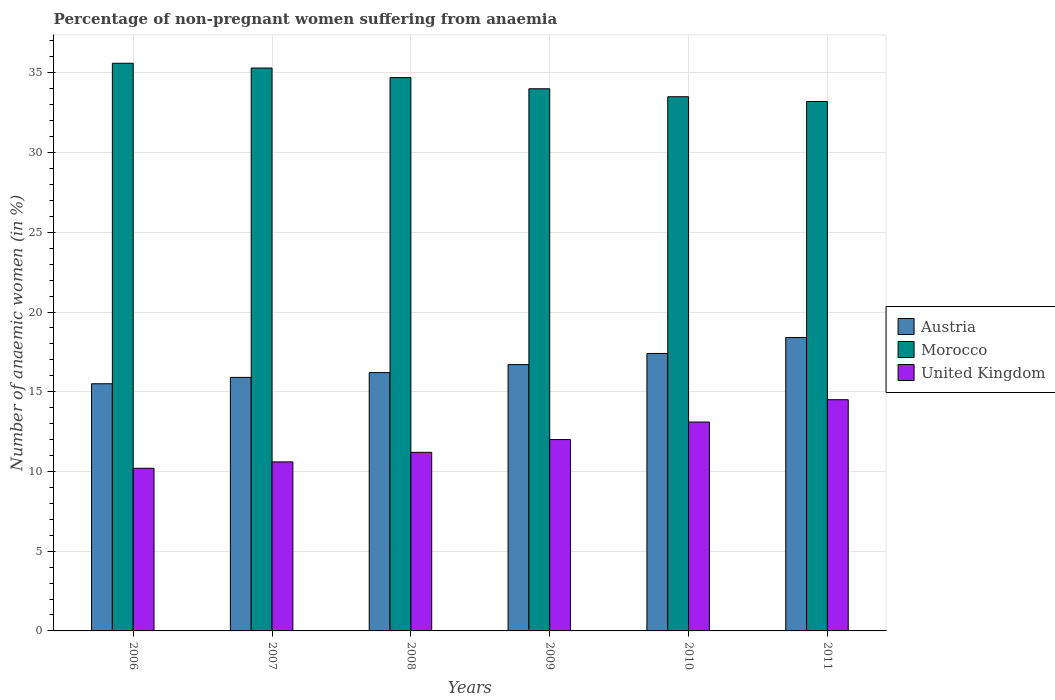How many different coloured bars are there?
Give a very brief answer. 3. Are the number of bars per tick equal to the number of legend labels?
Offer a terse response. Yes. What is the label of the 5th group of bars from the left?
Keep it short and to the point. 2010. In how many cases, is the number of bars for a given year not equal to the number of legend labels?
Provide a succinct answer. 0. Across all years, what is the maximum percentage of non-pregnant women suffering from anaemia in Morocco?
Provide a succinct answer. 35.6. What is the total percentage of non-pregnant women suffering from anaemia in Morocco in the graph?
Make the answer very short. 206.3. What is the difference between the percentage of non-pregnant women suffering from anaemia in Austria in 2008 and the percentage of non-pregnant women suffering from anaemia in Morocco in 2009?
Provide a short and direct response. -17.8. What is the average percentage of non-pregnant women suffering from anaemia in Austria per year?
Provide a succinct answer. 16.68. In the year 2009, what is the difference between the percentage of non-pregnant women suffering from anaemia in Austria and percentage of non-pregnant women suffering from anaemia in Morocco?
Offer a terse response. -17.3. What is the ratio of the percentage of non-pregnant women suffering from anaemia in Austria in 2007 to that in 2009?
Your answer should be compact. 0.95. Is the percentage of non-pregnant women suffering from anaemia in Austria in 2009 less than that in 2011?
Your answer should be very brief. Yes. Is the difference between the percentage of non-pregnant women suffering from anaemia in Austria in 2007 and 2010 greater than the difference between the percentage of non-pregnant women suffering from anaemia in Morocco in 2007 and 2010?
Ensure brevity in your answer.  No. What is the difference between the highest and the second highest percentage of non-pregnant women suffering from anaemia in Morocco?
Give a very brief answer. 0.3. What is the difference between the highest and the lowest percentage of non-pregnant women suffering from anaemia in Morocco?
Provide a short and direct response. 2.4. What does the 2nd bar from the left in 2008 represents?
Give a very brief answer. Morocco. Is it the case that in every year, the sum of the percentage of non-pregnant women suffering from anaemia in Austria and percentage of non-pregnant women suffering from anaemia in United Kingdom is greater than the percentage of non-pregnant women suffering from anaemia in Morocco?
Your answer should be very brief. No. What is the difference between two consecutive major ticks on the Y-axis?
Your answer should be compact. 5. Does the graph contain any zero values?
Your response must be concise. No. Does the graph contain grids?
Provide a succinct answer. Yes. What is the title of the graph?
Your response must be concise. Percentage of non-pregnant women suffering from anaemia. What is the label or title of the X-axis?
Provide a short and direct response. Years. What is the label or title of the Y-axis?
Ensure brevity in your answer.  Number of anaemic women (in %). What is the Number of anaemic women (in %) in Austria in 2006?
Your answer should be compact. 15.5. What is the Number of anaemic women (in %) in Morocco in 2006?
Your answer should be compact. 35.6. What is the Number of anaemic women (in %) of Morocco in 2007?
Provide a succinct answer. 35.3. What is the Number of anaemic women (in %) in United Kingdom in 2007?
Provide a short and direct response. 10.6. What is the Number of anaemic women (in %) in Morocco in 2008?
Your answer should be compact. 34.7. What is the Number of anaemic women (in %) in United Kingdom in 2008?
Provide a short and direct response. 11.2. What is the Number of anaemic women (in %) of Austria in 2009?
Your answer should be very brief. 16.7. What is the Number of anaemic women (in %) of Morocco in 2009?
Provide a short and direct response. 34. What is the Number of anaemic women (in %) of Austria in 2010?
Offer a very short reply. 17.4. What is the Number of anaemic women (in %) in Morocco in 2010?
Keep it short and to the point. 33.5. What is the Number of anaemic women (in %) of United Kingdom in 2010?
Give a very brief answer. 13.1. What is the Number of anaemic women (in %) of Morocco in 2011?
Your answer should be compact. 33.2. Across all years, what is the maximum Number of anaemic women (in %) in Morocco?
Offer a terse response. 35.6. Across all years, what is the maximum Number of anaemic women (in %) of United Kingdom?
Ensure brevity in your answer.  14.5. Across all years, what is the minimum Number of anaemic women (in %) of Austria?
Make the answer very short. 15.5. Across all years, what is the minimum Number of anaemic women (in %) of Morocco?
Provide a short and direct response. 33.2. What is the total Number of anaemic women (in %) of Austria in the graph?
Offer a terse response. 100.1. What is the total Number of anaemic women (in %) in Morocco in the graph?
Provide a short and direct response. 206.3. What is the total Number of anaemic women (in %) in United Kingdom in the graph?
Your response must be concise. 71.6. What is the difference between the Number of anaemic women (in %) in Austria in 2006 and that in 2007?
Your answer should be very brief. -0.4. What is the difference between the Number of anaemic women (in %) of Morocco in 2006 and that in 2008?
Make the answer very short. 0.9. What is the difference between the Number of anaemic women (in %) of United Kingdom in 2006 and that in 2008?
Your answer should be compact. -1. What is the difference between the Number of anaemic women (in %) in Morocco in 2006 and that in 2009?
Your answer should be compact. 1.6. What is the difference between the Number of anaemic women (in %) of United Kingdom in 2006 and that in 2009?
Keep it short and to the point. -1.8. What is the difference between the Number of anaemic women (in %) in Austria in 2006 and that in 2010?
Ensure brevity in your answer.  -1.9. What is the difference between the Number of anaemic women (in %) of Morocco in 2006 and that in 2011?
Offer a very short reply. 2.4. What is the difference between the Number of anaemic women (in %) in United Kingdom in 2006 and that in 2011?
Provide a succinct answer. -4.3. What is the difference between the Number of anaemic women (in %) in Morocco in 2007 and that in 2008?
Your response must be concise. 0.6. What is the difference between the Number of anaemic women (in %) of Austria in 2007 and that in 2009?
Your response must be concise. -0.8. What is the difference between the Number of anaemic women (in %) of Morocco in 2007 and that in 2009?
Make the answer very short. 1.3. What is the difference between the Number of anaemic women (in %) in United Kingdom in 2007 and that in 2009?
Your answer should be compact. -1.4. What is the difference between the Number of anaemic women (in %) of Morocco in 2007 and that in 2010?
Your answer should be very brief. 1.8. What is the difference between the Number of anaemic women (in %) in United Kingdom in 2007 and that in 2010?
Provide a short and direct response. -2.5. What is the difference between the Number of anaemic women (in %) in Austria in 2007 and that in 2011?
Provide a short and direct response. -2.5. What is the difference between the Number of anaemic women (in %) of Morocco in 2007 and that in 2011?
Make the answer very short. 2.1. What is the difference between the Number of anaemic women (in %) of Morocco in 2008 and that in 2009?
Your answer should be very brief. 0.7. What is the difference between the Number of anaemic women (in %) of Morocco in 2008 and that in 2010?
Offer a very short reply. 1.2. What is the difference between the Number of anaemic women (in %) of United Kingdom in 2008 and that in 2010?
Ensure brevity in your answer.  -1.9. What is the difference between the Number of anaemic women (in %) of United Kingdom in 2008 and that in 2011?
Provide a succinct answer. -3.3. What is the difference between the Number of anaemic women (in %) in Austria in 2009 and that in 2010?
Make the answer very short. -0.7. What is the difference between the Number of anaemic women (in %) in Morocco in 2009 and that in 2010?
Keep it short and to the point. 0.5. What is the difference between the Number of anaemic women (in %) of United Kingdom in 2009 and that in 2010?
Your answer should be compact. -1.1. What is the difference between the Number of anaemic women (in %) of Morocco in 2009 and that in 2011?
Make the answer very short. 0.8. What is the difference between the Number of anaemic women (in %) in United Kingdom in 2010 and that in 2011?
Offer a terse response. -1.4. What is the difference between the Number of anaemic women (in %) of Austria in 2006 and the Number of anaemic women (in %) of Morocco in 2007?
Provide a succinct answer. -19.8. What is the difference between the Number of anaemic women (in %) in Austria in 2006 and the Number of anaemic women (in %) in United Kingdom in 2007?
Your answer should be compact. 4.9. What is the difference between the Number of anaemic women (in %) in Morocco in 2006 and the Number of anaemic women (in %) in United Kingdom in 2007?
Give a very brief answer. 25. What is the difference between the Number of anaemic women (in %) of Austria in 2006 and the Number of anaemic women (in %) of Morocco in 2008?
Provide a succinct answer. -19.2. What is the difference between the Number of anaemic women (in %) in Austria in 2006 and the Number of anaemic women (in %) in United Kingdom in 2008?
Provide a short and direct response. 4.3. What is the difference between the Number of anaemic women (in %) in Morocco in 2006 and the Number of anaemic women (in %) in United Kingdom in 2008?
Offer a very short reply. 24.4. What is the difference between the Number of anaemic women (in %) in Austria in 2006 and the Number of anaemic women (in %) in Morocco in 2009?
Your answer should be compact. -18.5. What is the difference between the Number of anaemic women (in %) of Morocco in 2006 and the Number of anaemic women (in %) of United Kingdom in 2009?
Make the answer very short. 23.6. What is the difference between the Number of anaemic women (in %) of Austria in 2006 and the Number of anaemic women (in %) of Morocco in 2010?
Provide a short and direct response. -18. What is the difference between the Number of anaemic women (in %) in Austria in 2006 and the Number of anaemic women (in %) in United Kingdom in 2010?
Your answer should be compact. 2.4. What is the difference between the Number of anaemic women (in %) in Morocco in 2006 and the Number of anaemic women (in %) in United Kingdom in 2010?
Provide a succinct answer. 22.5. What is the difference between the Number of anaemic women (in %) of Austria in 2006 and the Number of anaemic women (in %) of Morocco in 2011?
Make the answer very short. -17.7. What is the difference between the Number of anaemic women (in %) of Morocco in 2006 and the Number of anaemic women (in %) of United Kingdom in 2011?
Offer a terse response. 21.1. What is the difference between the Number of anaemic women (in %) of Austria in 2007 and the Number of anaemic women (in %) of Morocco in 2008?
Provide a short and direct response. -18.8. What is the difference between the Number of anaemic women (in %) of Morocco in 2007 and the Number of anaemic women (in %) of United Kingdom in 2008?
Give a very brief answer. 24.1. What is the difference between the Number of anaemic women (in %) of Austria in 2007 and the Number of anaemic women (in %) of Morocco in 2009?
Ensure brevity in your answer.  -18.1. What is the difference between the Number of anaemic women (in %) in Austria in 2007 and the Number of anaemic women (in %) in United Kingdom in 2009?
Offer a terse response. 3.9. What is the difference between the Number of anaemic women (in %) in Morocco in 2007 and the Number of anaemic women (in %) in United Kingdom in 2009?
Make the answer very short. 23.3. What is the difference between the Number of anaemic women (in %) of Austria in 2007 and the Number of anaemic women (in %) of Morocco in 2010?
Offer a terse response. -17.6. What is the difference between the Number of anaemic women (in %) in Austria in 2007 and the Number of anaemic women (in %) in United Kingdom in 2010?
Provide a succinct answer. 2.8. What is the difference between the Number of anaemic women (in %) in Austria in 2007 and the Number of anaemic women (in %) in Morocco in 2011?
Keep it short and to the point. -17.3. What is the difference between the Number of anaemic women (in %) of Morocco in 2007 and the Number of anaemic women (in %) of United Kingdom in 2011?
Provide a succinct answer. 20.8. What is the difference between the Number of anaemic women (in %) in Austria in 2008 and the Number of anaemic women (in %) in Morocco in 2009?
Offer a terse response. -17.8. What is the difference between the Number of anaemic women (in %) in Austria in 2008 and the Number of anaemic women (in %) in United Kingdom in 2009?
Provide a short and direct response. 4.2. What is the difference between the Number of anaemic women (in %) of Morocco in 2008 and the Number of anaemic women (in %) of United Kingdom in 2009?
Your answer should be compact. 22.7. What is the difference between the Number of anaemic women (in %) in Austria in 2008 and the Number of anaemic women (in %) in Morocco in 2010?
Provide a short and direct response. -17.3. What is the difference between the Number of anaemic women (in %) of Morocco in 2008 and the Number of anaemic women (in %) of United Kingdom in 2010?
Give a very brief answer. 21.6. What is the difference between the Number of anaemic women (in %) in Austria in 2008 and the Number of anaemic women (in %) in Morocco in 2011?
Your answer should be very brief. -17. What is the difference between the Number of anaemic women (in %) in Morocco in 2008 and the Number of anaemic women (in %) in United Kingdom in 2011?
Your answer should be very brief. 20.2. What is the difference between the Number of anaemic women (in %) of Austria in 2009 and the Number of anaemic women (in %) of Morocco in 2010?
Give a very brief answer. -16.8. What is the difference between the Number of anaemic women (in %) of Morocco in 2009 and the Number of anaemic women (in %) of United Kingdom in 2010?
Provide a succinct answer. 20.9. What is the difference between the Number of anaemic women (in %) of Austria in 2009 and the Number of anaemic women (in %) of Morocco in 2011?
Ensure brevity in your answer.  -16.5. What is the difference between the Number of anaemic women (in %) in Morocco in 2009 and the Number of anaemic women (in %) in United Kingdom in 2011?
Offer a terse response. 19.5. What is the difference between the Number of anaemic women (in %) in Austria in 2010 and the Number of anaemic women (in %) in Morocco in 2011?
Offer a terse response. -15.8. What is the difference between the Number of anaemic women (in %) in Austria in 2010 and the Number of anaemic women (in %) in United Kingdom in 2011?
Offer a terse response. 2.9. What is the average Number of anaemic women (in %) of Austria per year?
Make the answer very short. 16.68. What is the average Number of anaemic women (in %) of Morocco per year?
Your answer should be very brief. 34.38. What is the average Number of anaemic women (in %) in United Kingdom per year?
Keep it short and to the point. 11.93. In the year 2006, what is the difference between the Number of anaemic women (in %) in Austria and Number of anaemic women (in %) in Morocco?
Make the answer very short. -20.1. In the year 2006, what is the difference between the Number of anaemic women (in %) of Austria and Number of anaemic women (in %) of United Kingdom?
Your answer should be compact. 5.3. In the year 2006, what is the difference between the Number of anaemic women (in %) of Morocco and Number of anaemic women (in %) of United Kingdom?
Your answer should be compact. 25.4. In the year 2007, what is the difference between the Number of anaemic women (in %) in Austria and Number of anaemic women (in %) in Morocco?
Give a very brief answer. -19.4. In the year 2007, what is the difference between the Number of anaemic women (in %) in Morocco and Number of anaemic women (in %) in United Kingdom?
Offer a very short reply. 24.7. In the year 2008, what is the difference between the Number of anaemic women (in %) of Austria and Number of anaemic women (in %) of Morocco?
Provide a succinct answer. -18.5. In the year 2008, what is the difference between the Number of anaemic women (in %) of Austria and Number of anaemic women (in %) of United Kingdom?
Offer a terse response. 5. In the year 2008, what is the difference between the Number of anaemic women (in %) in Morocco and Number of anaemic women (in %) in United Kingdom?
Offer a terse response. 23.5. In the year 2009, what is the difference between the Number of anaemic women (in %) in Austria and Number of anaemic women (in %) in Morocco?
Your answer should be compact. -17.3. In the year 2009, what is the difference between the Number of anaemic women (in %) of Morocco and Number of anaemic women (in %) of United Kingdom?
Keep it short and to the point. 22. In the year 2010, what is the difference between the Number of anaemic women (in %) in Austria and Number of anaemic women (in %) in Morocco?
Ensure brevity in your answer.  -16.1. In the year 2010, what is the difference between the Number of anaemic women (in %) in Austria and Number of anaemic women (in %) in United Kingdom?
Provide a succinct answer. 4.3. In the year 2010, what is the difference between the Number of anaemic women (in %) in Morocco and Number of anaemic women (in %) in United Kingdom?
Ensure brevity in your answer.  20.4. In the year 2011, what is the difference between the Number of anaemic women (in %) of Austria and Number of anaemic women (in %) of Morocco?
Your answer should be very brief. -14.8. What is the ratio of the Number of anaemic women (in %) of Austria in 2006 to that in 2007?
Offer a terse response. 0.97. What is the ratio of the Number of anaemic women (in %) of Morocco in 2006 to that in 2007?
Provide a short and direct response. 1.01. What is the ratio of the Number of anaemic women (in %) of United Kingdom in 2006 to that in 2007?
Ensure brevity in your answer.  0.96. What is the ratio of the Number of anaemic women (in %) in Austria in 2006 to that in 2008?
Give a very brief answer. 0.96. What is the ratio of the Number of anaemic women (in %) in Morocco in 2006 to that in 2008?
Offer a terse response. 1.03. What is the ratio of the Number of anaemic women (in %) of United Kingdom in 2006 to that in 2008?
Provide a succinct answer. 0.91. What is the ratio of the Number of anaemic women (in %) in Austria in 2006 to that in 2009?
Offer a terse response. 0.93. What is the ratio of the Number of anaemic women (in %) of Morocco in 2006 to that in 2009?
Your response must be concise. 1.05. What is the ratio of the Number of anaemic women (in %) in United Kingdom in 2006 to that in 2009?
Your response must be concise. 0.85. What is the ratio of the Number of anaemic women (in %) in Austria in 2006 to that in 2010?
Offer a very short reply. 0.89. What is the ratio of the Number of anaemic women (in %) of Morocco in 2006 to that in 2010?
Offer a terse response. 1.06. What is the ratio of the Number of anaemic women (in %) of United Kingdom in 2006 to that in 2010?
Your answer should be compact. 0.78. What is the ratio of the Number of anaemic women (in %) of Austria in 2006 to that in 2011?
Keep it short and to the point. 0.84. What is the ratio of the Number of anaemic women (in %) of Morocco in 2006 to that in 2011?
Provide a succinct answer. 1.07. What is the ratio of the Number of anaemic women (in %) in United Kingdom in 2006 to that in 2011?
Your answer should be very brief. 0.7. What is the ratio of the Number of anaemic women (in %) in Austria in 2007 to that in 2008?
Provide a short and direct response. 0.98. What is the ratio of the Number of anaemic women (in %) in Morocco in 2007 to that in 2008?
Keep it short and to the point. 1.02. What is the ratio of the Number of anaemic women (in %) of United Kingdom in 2007 to that in 2008?
Provide a short and direct response. 0.95. What is the ratio of the Number of anaemic women (in %) of Austria in 2007 to that in 2009?
Ensure brevity in your answer.  0.95. What is the ratio of the Number of anaemic women (in %) in Morocco in 2007 to that in 2009?
Offer a terse response. 1.04. What is the ratio of the Number of anaemic women (in %) of United Kingdom in 2007 to that in 2009?
Provide a short and direct response. 0.88. What is the ratio of the Number of anaemic women (in %) in Austria in 2007 to that in 2010?
Provide a short and direct response. 0.91. What is the ratio of the Number of anaemic women (in %) in Morocco in 2007 to that in 2010?
Offer a terse response. 1.05. What is the ratio of the Number of anaemic women (in %) of United Kingdom in 2007 to that in 2010?
Give a very brief answer. 0.81. What is the ratio of the Number of anaemic women (in %) in Austria in 2007 to that in 2011?
Your response must be concise. 0.86. What is the ratio of the Number of anaemic women (in %) in Morocco in 2007 to that in 2011?
Offer a very short reply. 1.06. What is the ratio of the Number of anaemic women (in %) of United Kingdom in 2007 to that in 2011?
Keep it short and to the point. 0.73. What is the ratio of the Number of anaemic women (in %) in Austria in 2008 to that in 2009?
Offer a terse response. 0.97. What is the ratio of the Number of anaemic women (in %) of Morocco in 2008 to that in 2009?
Give a very brief answer. 1.02. What is the ratio of the Number of anaemic women (in %) in Austria in 2008 to that in 2010?
Offer a terse response. 0.93. What is the ratio of the Number of anaemic women (in %) in Morocco in 2008 to that in 2010?
Your response must be concise. 1.04. What is the ratio of the Number of anaemic women (in %) in United Kingdom in 2008 to that in 2010?
Offer a very short reply. 0.85. What is the ratio of the Number of anaemic women (in %) in Austria in 2008 to that in 2011?
Make the answer very short. 0.88. What is the ratio of the Number of anaemic women (in %) in Morocco in 2008 to that in 2011?
Keep it short and to the point. 1.05. What is the ratio of the Number of anaemic women (in %) of United Kingdom in 2008 to that in 2011?
Provide a succinct answer. 0.77. What is the ratio of the Number of anaemic women (in %) in Austria in 2009 to that in 2010?
Make the answer very short. 0.96. What is the ratio of the Number of anaemic women (in %) of Morocco in 2009 to that in 2010?
Offer a very short reply. 1.01. What is the ratio of the Number of anaemic women (in %) of United Kingdom in 2009 to that in 2010?
Offer a terse response. 0.92. What is the ratio of the Number of anaemic women (in %) of Austria in 2009 to that in 2011?
Your answer should be compact. 0.91. What is the ratio of the Number of anaemic women (in %) in Morocco in 2009 to that in 2011?
Keep it short and to the point. 1.02. What is the ratio of the Number of anaemic women (in %) of United Kingdom in 2009 to that in 2011?
Provide a succinct answer. 0.83. What is the ratio of the Number of anaemic women (in %) in Austria in 2010 to that in 2011?
Provide a short and direct response. 0.95. What is the ratio of the Number of anaemic women (in %) of Morocco in 2010 to that in 2011?
Your answer should be compact. 1.01. What is the ratio of the Number of anaemic women (in %) in United Kingdom in 2010 to that in 2011?
Your answer should be very brief. 0.9. What is the difference between the highest and the second highest Number of anaemic women (in %) in Austria?
Your answer should be very brief. 1. What is the difference between the highest and the second highest Number of anaemic women (in %) of Morocco?
Offer a terse response. 0.3. What is the difference between the highest and the second highest Number of anaemic women (in %) in United Kingdom?
Give a very brief answer. 1.4. What is the difference between the highest and the lowest Number of anaemic women (in %) of Morocco?
Your answer should be compact. 2.4. What is the difference between the highest and the lowest Number of anaemic women (in %) in United Kingdom?
Your answer should be very brief. 4.3. 